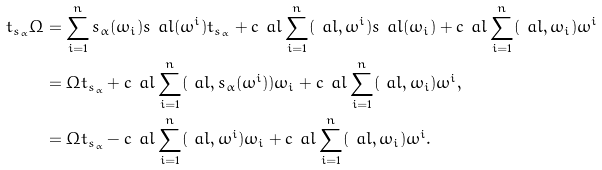<formula> <loc_0><loc_0><loc_500><loc_500>t _ { s _ { \alpha } } \Omega & = \sum _ { i = 1 } ^ { n } s _ { \alpha } ( \omega _ { i } ) s _ { \ } a l ( \omega ^ { i } ) t _ { s _ { \alpha } } + c _ { \ } a l \sum _ { i = 1 } ^ { n } ( \ a l , \omega ^ { i } ) s _ { \ } a l ( \omega _ { i } ) + c _ { \ } a l \sum _ { i = 1 } ^ { n } ( \ a l , \omega _ { i } ) \omega ^ { i } \\ & = \Omega t _ { s _ { \alpha } } + c _ { \ } a l \sum _ { i = 1 } ^ { n } ( \ a l , s _ { \alpha } ( \omega ^ { i } ) ) \omega _ { i } + c _ { \ } a l \sum _ { i = 1 } ^ { n } ( \ a l , \omega _ { i } ) \omega ^ { i } , \\ & = \Omega t _ { s _ { \alpha } } - c _ { \ } a l \sum _ { i = 1 } ^ { n } ( \ a l , \omega ^ { i } ) \omega _ { i } + c _ { \ } a l \sum _ { i = 1 } ^ { n } ( \ a l , \omega _ { i } ) \omega ^ { i } .</formula> 